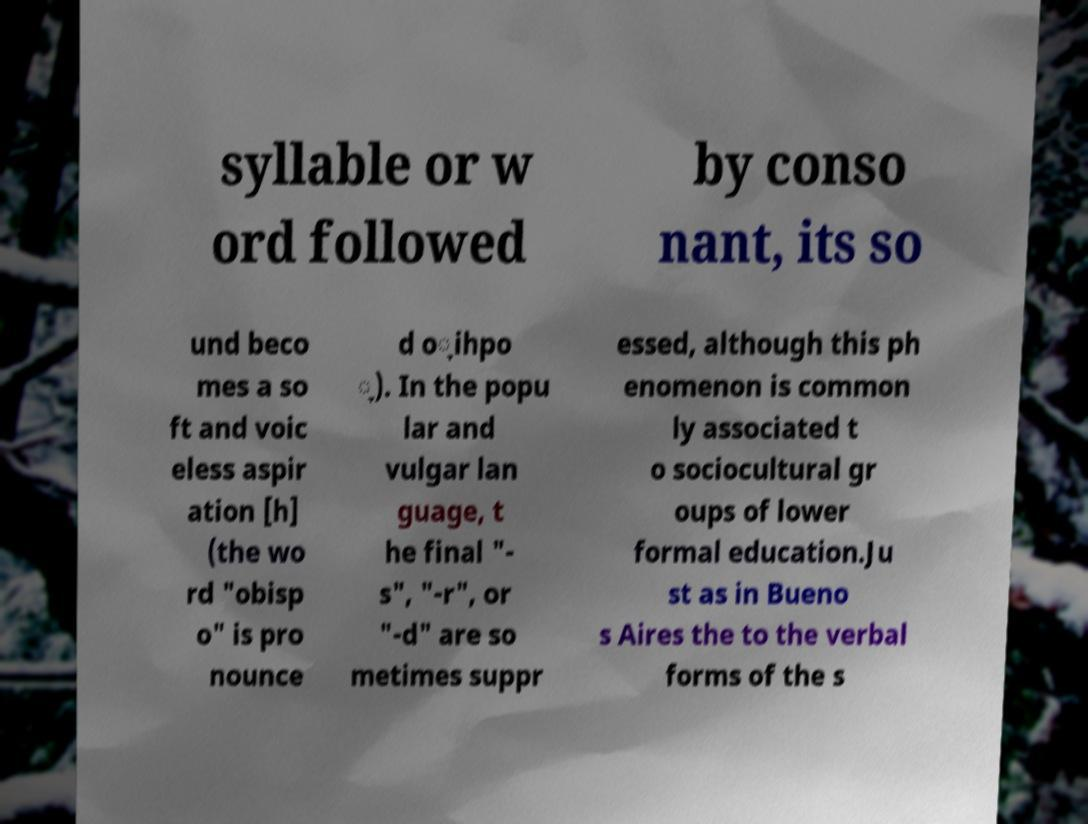Could you extract and type out the text from this image? syllable or w ord followed by conso nant, its so und beco mes a so ft and voic eless aspir ation [h] (the wo rd "obisp o" is pro nounce d o̞ihpo ̞). In the popu lar and vulgar lan guage, t he final "- s", "-r", or "-d" are so metimes suppr essed, although this ph enomenon is common ly associated t o sociocultural gr oups of lower formal education.Ju st as in Bueno s Aires the to the verbal forms of the s 